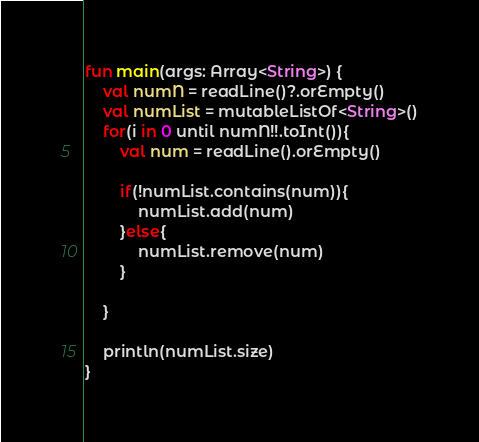<code> <loc_0><loc_0><loc_500><loc_500><_Kotlin_>fun main(args: Array<String>) {
    val numN = readLine()?.orEmpty()
    val numList = mutableListOf<String>()
    for(i in 0 until numN!!.toInt()){
        val num = readLine().orEmpty()

        if(!numList.contains(num)){
            numList.add(num)
        }else{
            numList.remove(num)
        }

    }

    println(numList.size)
}</code> 